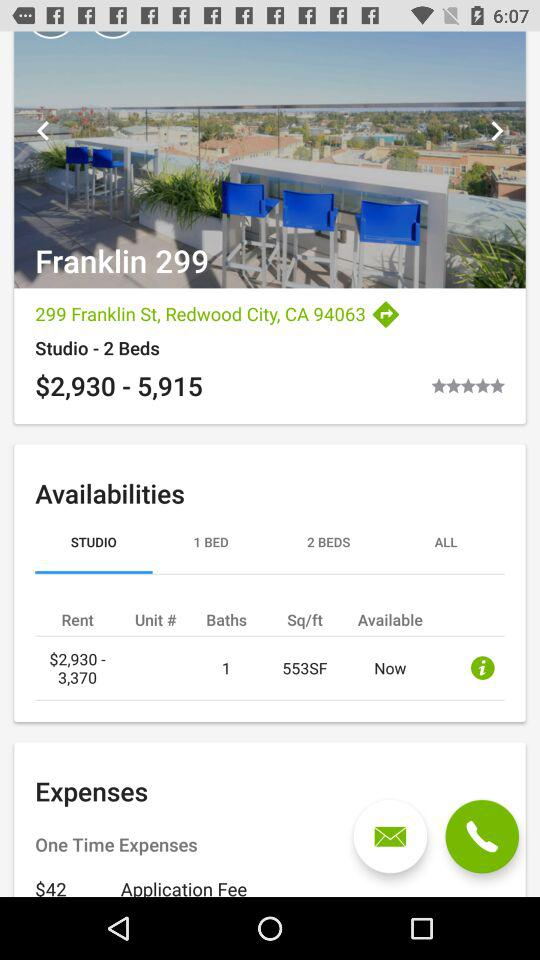What is the location? The location is 299 Franklin St., Redwood City, CA 94063. 